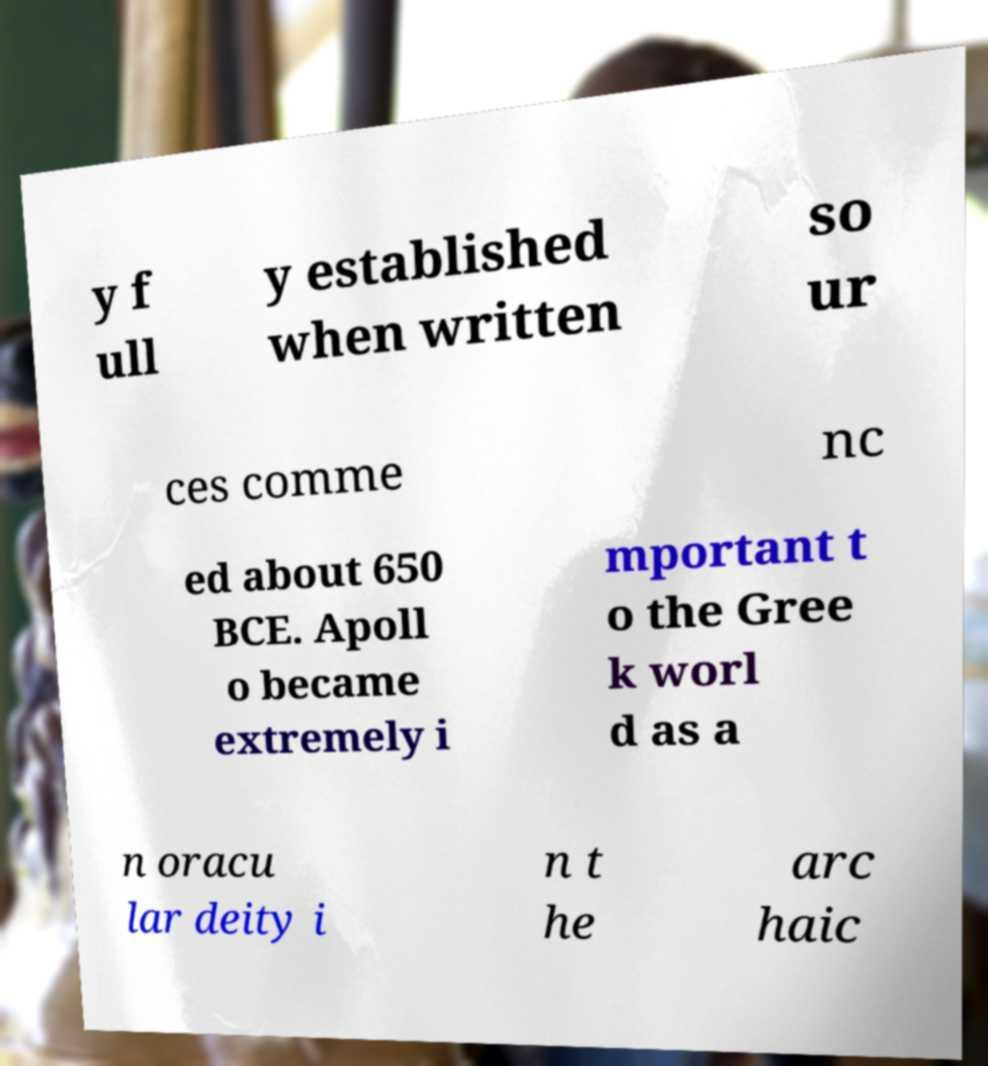For documentation purposes, I need the text within this image transcribed. Could you provide that? y f ull y established when written so ur ces comme nc ed about 650 BCE. Apoll o became extremely i mportant t o the Gree k worl d as a n oracu lar deity i n t he arc haic 